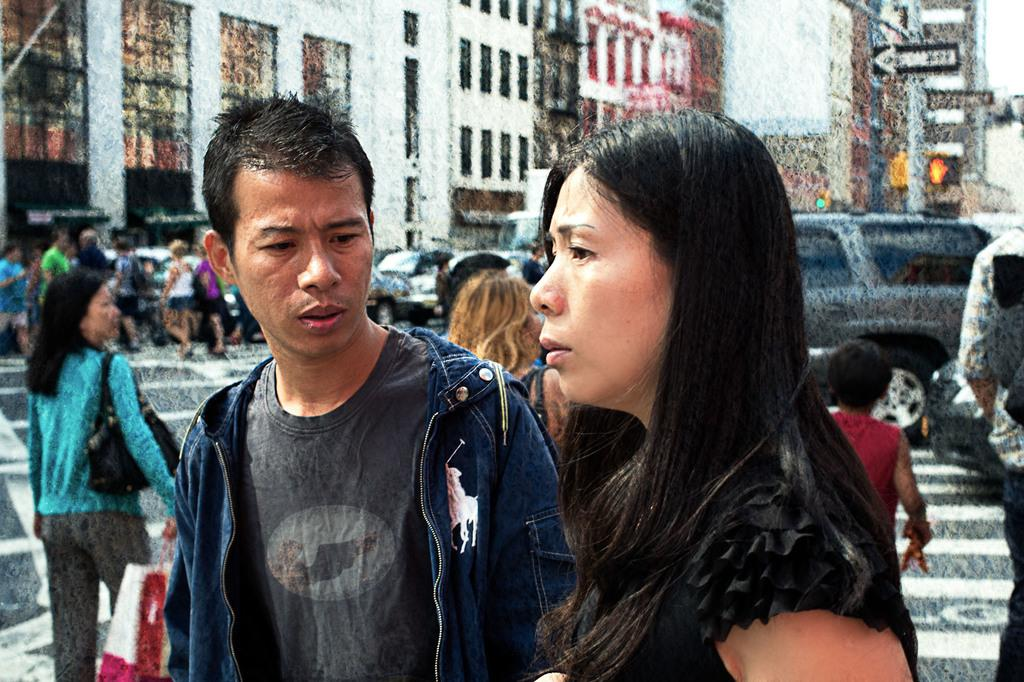How many people are present in the image? There are two people in the image. What is the man doing in the image? One man is looking at a woman in the image. Can you describe the background of the image? There are people, buildings, signboards, and vehicles visible in the background. What is the size of the month in the image? There is no month present in the image, as it is a photograph of people and a background setting. What sense is being used by the man looking at the woman in the image? The man is likely using his sense of sight to look at the woman, but we cannot determine this definitively from the image alone. 